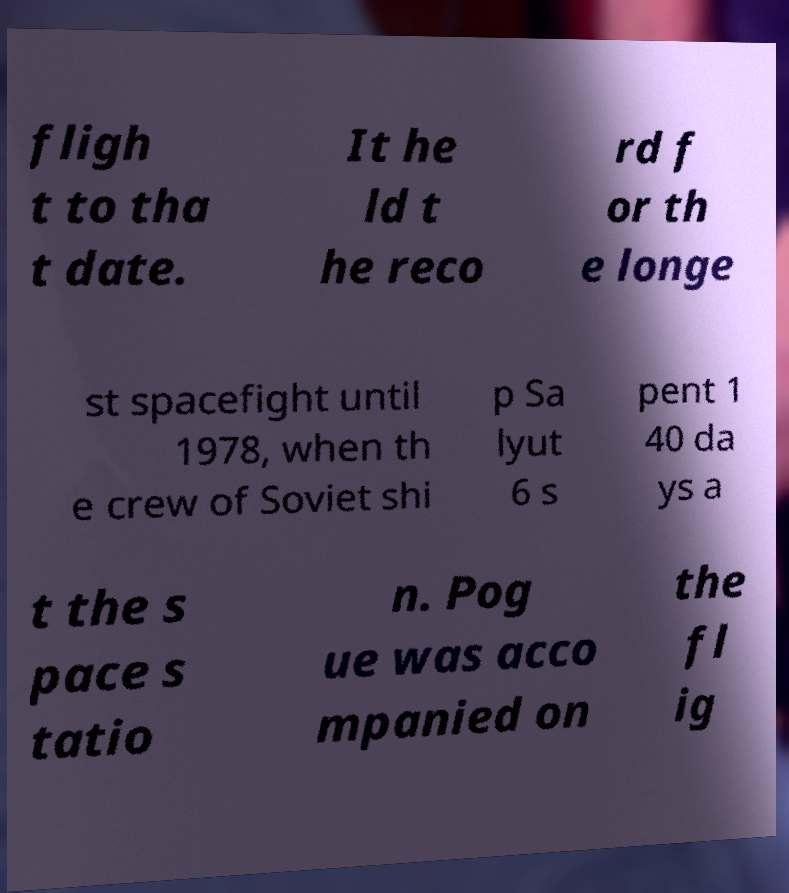Could you extract and type out the text from this image? fligh t to tha t date. It he ld t he reco rd f or th e longe st spacefight until 1978, when th e crew of Soviet shi p Sa lyut 6 s pent 1 40 da ys a t the s pace s tatio n. Pog ue was acco mpanied on the fl ig 